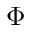Convert formula to latex. <formula><loc_0><loc_0><loc_500><loc_500>\Phi</formula> 